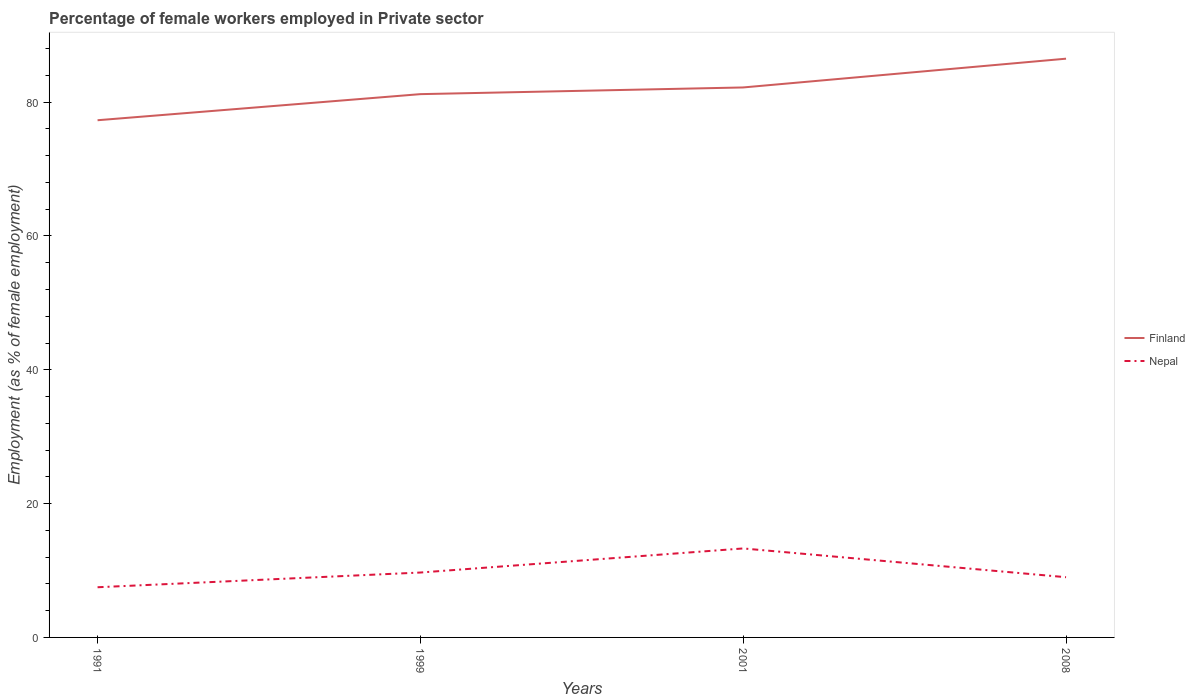Is the number of lines equal to the number of legend labels?
Offer a very short reply. Yes. Across all years, what is the maximum percentage of females employed in Private sector in Nepal?
Offer a terse response. 7.5. In which year was the percentage of females employed in Private sector in Nepal maximum?
Your answer should be very brief. 1991. What is the total percentage of females employed in Private sector in Finland in the graph?
Your answer should be very brief. -9.2. What is the difference between the highest and the second highest percentage of females employed in Private sector in Finland?
Keep it short and to the point. 9.2. Is the percentage of females employed in Private sector in Nepal strictly greater than the percentage of females employed in Private sector in Finland over the years?
Provide a short and direct response. Yes. How many lines are there?
Your answer should be very brief. 2. How many years are there in the graph?
Your answer should be very brief. 4. Does the graph contain any zero values?
Provide a short and direct response. No. Does the graph contain grids?
Ensure brevity in your answer.  No. Where does the legend appear in the graph?
Provide a succinct answer. Center right. How many legend labels are there?
Make the answer very short. 2. How are the legend labels stacked?
Offer a very short reply. Vertical. What is the title of the graph?
Your response must be concise. Percentage of female workers employed in Private sector. What is the label or title of the Y-axis?
Offer a terse response. Employment (as % of female employment). What is the Employment (as % of female employment) in Finland in 1991?
Offer a terse response. 77.3. What is the Employment (as % of female employment) of Nepal in 1991?
Your answer should be compact. 7.5. What is the Employment (as % of female employment) in Finland in 1999?
Offer a very short reply. 81.2. What is the Employment (as % of female employment) in Nepal in 1999?
Make the answer very short. 9.7. What is the Employment (as % of female employment) of Finland in 2001?
Give a very brief answer. 82.2. What is the Employment (as % of female employment) of Nepal in 2001?
Give a very brief answer. 13.3. What is the Employment (as % of female employment) in Finland in 2008?
Offer a very short reply. 86.5. Across all years, what is the maximum Employment (as % of female employment) in Finland?
Offer a terse response. 86.5. Across all years, what is the maximum Employment (as % of female employment) in Nepal?
Give a very brief answer. 13.3. Across all years, what is the minimum Employment (as % of female employment) of Finland?
Provide a succinct answer. 77.3. What is the total Employment (as % of female employment) in Finland in the graph?
Ensure brevity in your answer.  327.2. What is the total Employment (as % of female employment) of Nepal in the graph?
Make the answer very short. 39.5. What is the difference between the Employment (as % of female employment) of Nepal in 1991 and that in 2001?
Give a very brief answer. -5.8. What is the difference between the Employment (as % of female employment) of Finland in 1999 and that in 2001?
Offer a terse response. -1. What is the difference between the Employment (as % of female employment) of Nepal in 1999 and that in 2001?
Your answer should be very brief. -3.6. What is the difference between the Employment (as % of female employment) of Nepal in 1999 and that in 2008?
Your answer should be compact. 0.7. What is the difference between the Employment (as % of female employment) in Finland in 2001 and that in 2008?
Your response must be concise. -4.3. What is the difference between the Employment (as % of female employment) in Nepal in 2001 and that in 2008?
Your answer should be very brief. 4.3. What is the difference between the Employment (as % of female employment) in Finland in 1991 and the Employment (as % of female employment) in Nepal in 1999?
Provide a short and direct response. 67.6. What is the difference between the Employment (as % of female employment) in Finland in 1991 and the Employment (as % of female employment) in Nepal in 2008?
Provide a succinct answer. 68.3. What is the difference between the Employment (as % of female employment) of Finland in 1999 and the Employment (as % of female employment) of Nepal in 2001?
Provide a succinct answer. 67.9. What is the difference between the Employment (as % of female employment) of Finland in 1999 and the Employment (as % of female employment) of Nepal in 2008?
Your answer should be very brief. 72.2. What is the difference between the Employment (as % of female employment) of Finland in 2001 and the Employment (as % of female employment) of Nepal in 2008?
Your answer should be very brief. 73.2. What is the average Employment (as % of female employment) in Finland per year?
Provide a succinct answer. 81.8. What is the average Employment (as % of female employment) in Nepal per year?
Offer a terse response. 9.88. In the year 1991, what is the difference between the Employment (as % of female employment) in Finland and Employment (as % of female employment) in Nepal?
Make the answer very short. 69.8. In the year 1999, what is the difference between the Employment (as % of female employment) of Finland and Employment (as % of female employment) of Nepal?
Offer a terse response. 71.5. In the year 2001, what is the difference between the Employment (as % of female employment) of Finland and Employment (as % of female employment) of Nepal?
Make the answer very short. 68.9. In the year 2008, what is the difference between the Employment (as % of female employment) in Finland and Employment (as % of female employment) in Nepal?
Provide a short and direct response. 77.5. What is the ratio of the Employment (as % of female employment) of Nepal in 1991 to that in 1999?
Offer a very short reply. 0.77. What is the ratio of the Employment (as % of female employment) of Finland in 1991 to that in 2001?
Make the answer very short. 0.94. What is the ratio of the Employment (as % of female employment) of Nepal in 1991 to that in 2001?
Keep it short and to the point. 0.56. What is the ratio of the Employment (as % of female employment) of Finland in 1991 to that in 2008?
Provide a short and direct response. 0.89. What is the ratio of the Employment (as % of female employment) in Nepal in 1991 to that in 2008?
Provide a short and direct response. 0.83. What is the ratio of the Employment (as % of female employment) in Finland in 1999 to that in 2001?
Give a very brief answer. 0.99. What is the ratio of the Employment (as % of female employment) in Nepal in 1999 to that in 2001?
Offer a very short reply. 0.73. What is the ratio of the Employment (as % of female employment) in Finland in 1999 to that in 2008?
Offer a terse response. 0.94. What is the ratio of the Employment (as % of female employment) in Nepal in 1999 to that in 2008?
Make the answer very short. 1.08. What is the ratio of the Employment (as % of female employment) of Finland in 2001 to that in 2008?
Provide a succinct answer. 0.95. What is the ratio of the Employment (as % of female employment) of Nepal in 2001 to that in 2008?
Keep it short and to the point. 1.48. What is the difference between the highest and the second highest Employment (as % of female employment) in Finland?
Provide a short and direct response. 4.3. What is the difference between the highest and the lowest Employment (as % of female employment) in Nepal?
Ensure brevity in your answer.  5.8. 